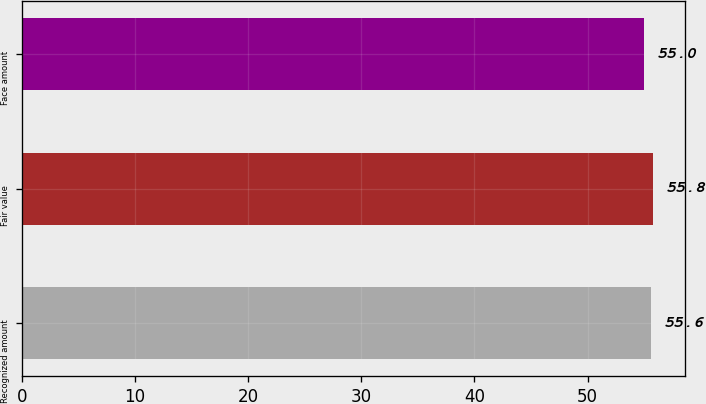Convert chart to OTSL. <chart><loc_0><loc_0><loc_500><loc_500><bar_chart><fcel>Recognized amount<fcel>Fair value<fcel>Face amount<nl><fcel>55.6<fcel>55.8<fcel>55<nl></chart> 